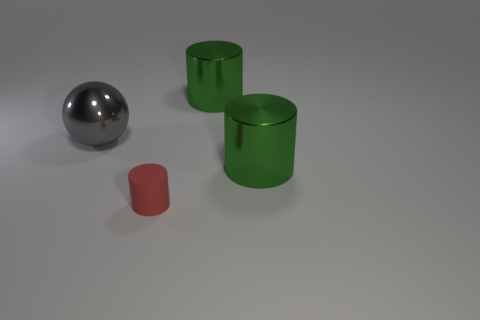Add 3 big gray metal objects. How many objects exist? 7 Subtract all spheres. How many objects are left? 3 Add 1 large gray shiny spheres. How many large gray shiny spheres are left? 2 Add 1 green shiny cylinders. How many green shiny cylinders exist? 3 Subtract 0 blue balls. How many objects are left? 4 Subtract all large brown rubber things. Subtract all cylinders. How many objects are left? 1 